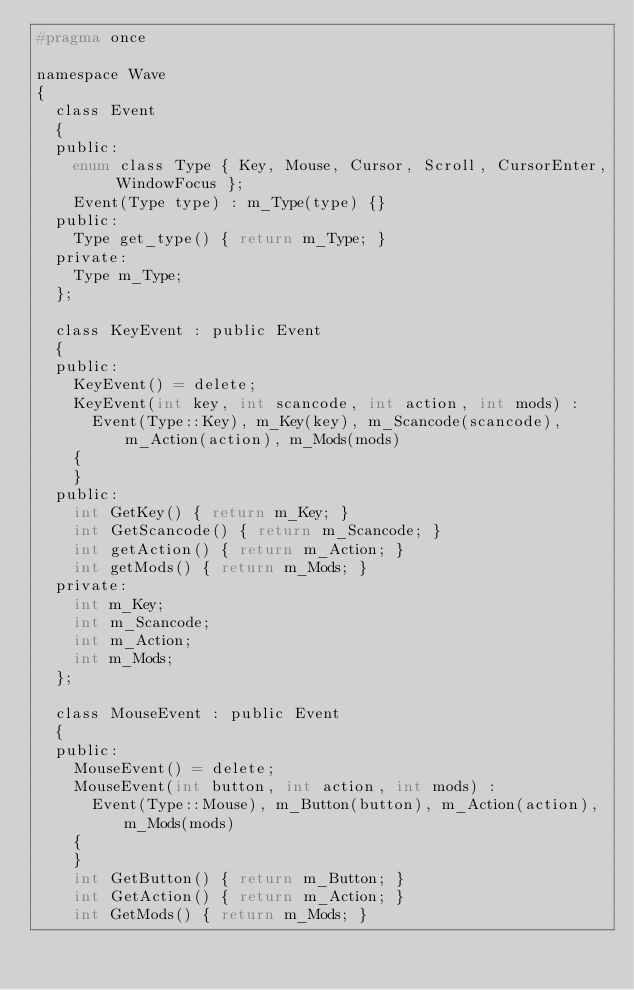Convert code to text. <code><loc_0><loc_0><loc_500><loc_500><_C_>#pragma once 

namespace Wave
{
	class Event
	{
	public:
		enum class Type { Key, Mouse, Cursor, Scroll, CursorEnter, WindowFocus };
		Event(Type type) : m_Type(type) {}
	public:
		Type get_type() { return m_Type; }
	private:
		Type m_Type;
	};

	class KeyEvent : public Event
	{
	public:
		KeyEvent() = delete;
		KeyEvent(int key, int scancode, int action, int mods) :
			Event(Type::Key), m_Key(key), m_Scancode(scancode), m_Action(action), m_Mods(mods)
		{
		}
	public:
		int GetKey() { return m_Key; }
		int GetScancode() { return m_Scancode; }
		int getAction() { return m_Action; }
		int getMods() { return m_Mods; }
	private:
		int m_Key;
		int m_Scancode;
		int m_Action;
		int m_Mods;
	};

	class MouseEvent : public Event
	{
	public:
		MouseEvent() = delete;
		MouseEvent(int button, int action, int mods) :
			Event(Type::Mouse), m_Button(button), m_Action(action), m_Mods(mods)
		{
		}
		int GetButton() { return m_Button; }
		int GetAction() { return m_Action; }
		int GetMods() { return m_Mods; }</code> 